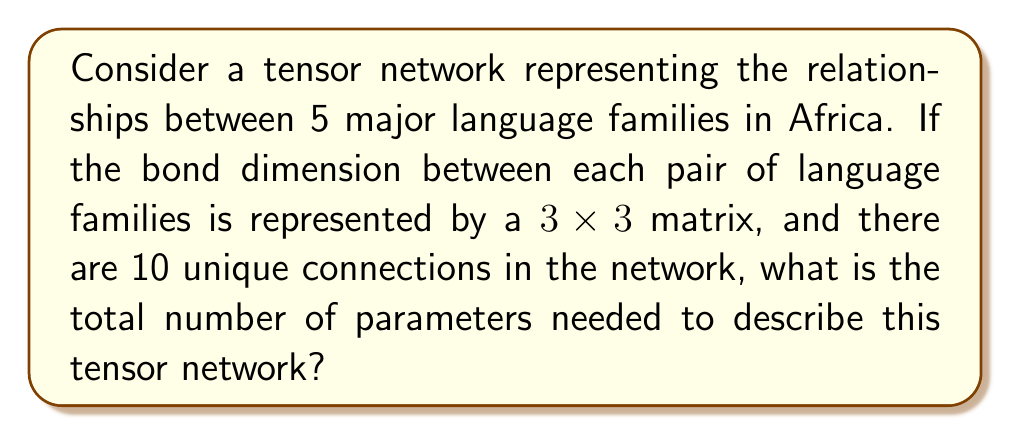Can you solve this math problem? To solve this problem, let's break it down into steps:

1. Understand the network structure:
   - We have 5 language families
   - Each connection between two families is represented by a $3 \times 3$ matrix
   - There are 10 unique connections in the network

2. Calculate the number of parameters in each connection:
   - A $3 \times 3$ matrix contains 9 elements
   - Each element is a parameter in our tensor network

3. Calculate the total number of parameters:
   - Number of parameters per connection: 9
   - Number of connections: 10
   - Total number of parameters: $9 \times 10 = 90$

The tensor network can be visualized as follows:

[asy]
unitsize(30);
pair[] nodes = {(0,0), (1,1), (2,0), (1,-1), (-1,0)};
for(int i = 0; i < 5; ++i)
  for(int j = i+1; j < 5; ++j)
    draw(nodes[i]--nodes[j], gray);
for(int i = 0; i < 5; ++i)
  dot(nodes[i]);
label("1", nodes[0], W);
label("2", nodes[1], N);
label("3", nodes[2], E);
label("4", nodes[3], S);
label("5", nodes[4], W);
[/asy]

Each line in this diagram represents a $3 \times 3$ matrix of parameters.

4. Interpretation for linguistics:
   This tensor network could represent the relationships and similarities between different language families in Africa. The parameters in each $3 \times 3$ matrix might represent various linguistic features or historical connections between the families.
Answer: 90 parameters 